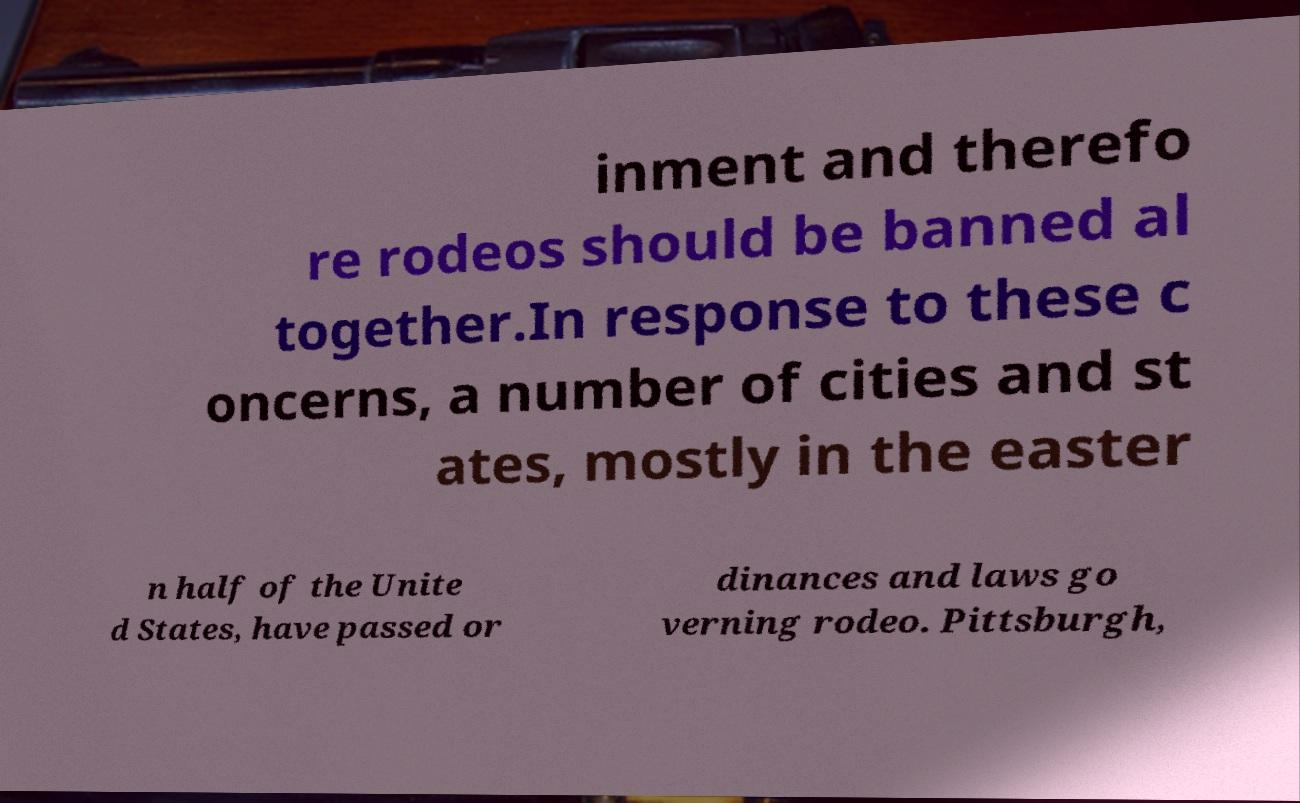I need the written content from this picture converted into text. Can you do that? inment and therefo re rodeos should be banned al together.In response to these c oncerns, a number of cities and st ates, mostly in the easter n half of the Unite d States, have passed or dinances and laws go verning rodeo. Pittsburgh, 